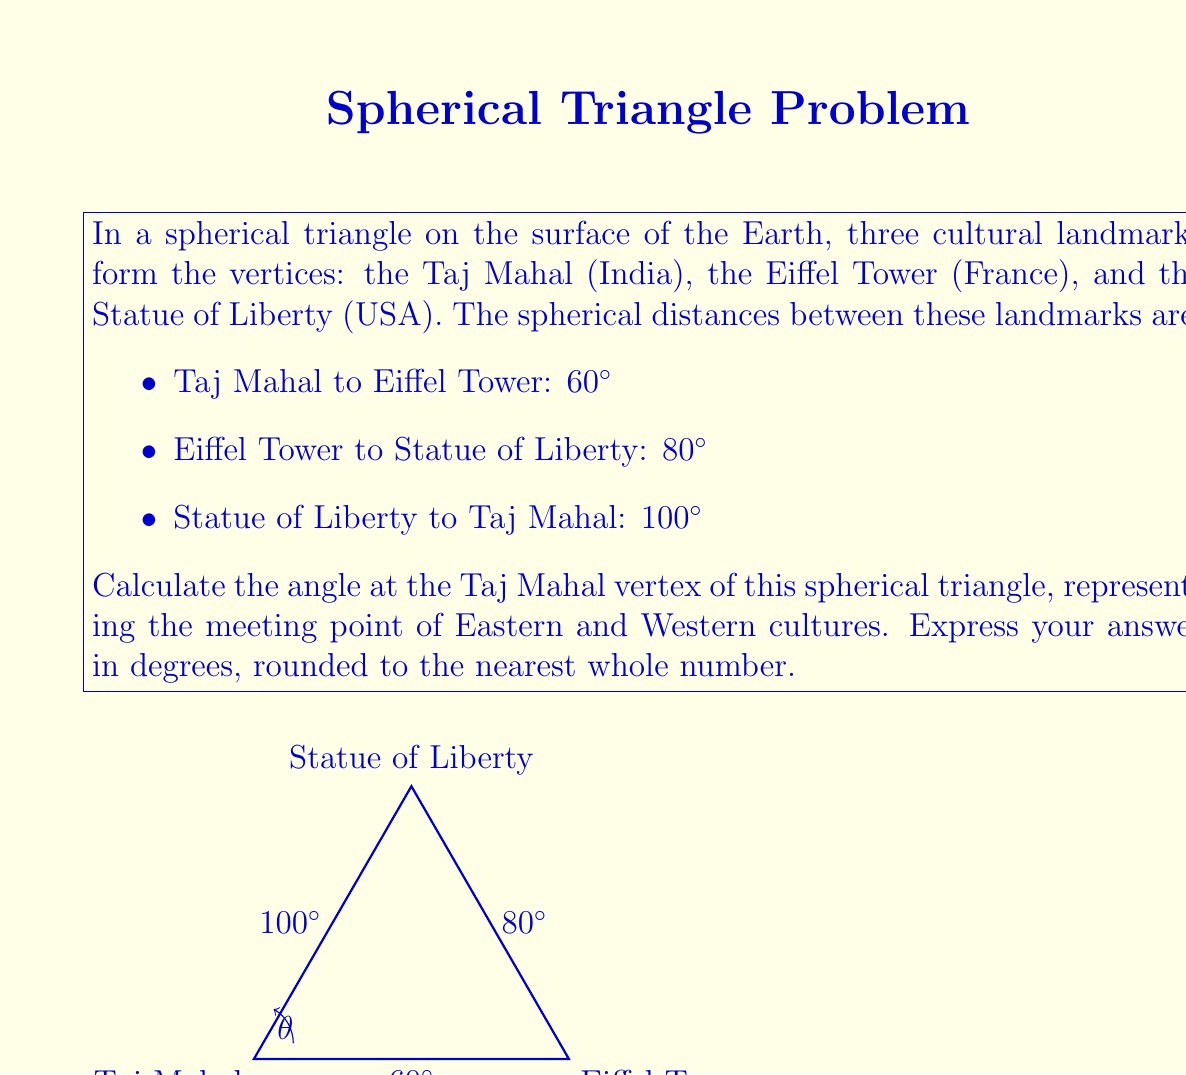Can you answer this question? To solve this problem, we'll use the spherical law of cosines. Let's denote the angle at the Taj Mahal as $\theta$, and the sides opposite to Taj Mahal, Eiffel Tower, and Statue of Liberty as $a$, $b$, and $c$ respectively.

Given:
$a = 80^\circ$, $b = 100^\circ$, $c = 60^\circ$

The spherical law of cosines states:

$$\cos(a) = \cos(b)\cos(c) + \sin(b)\sin(c)\cos(\theta)$$

Rearranging this equation to solve for $\cos(\theta)$:

$$\cos(\theta) = \frac{\cos(a) - \cos(b)\cos(c)}{\sin(b)\sin(c)}$$

Step 1: Calculate $\cos(a)$, $\cos(b)$, $\cos(c)$, $\sin(b)$, and $\sin(c)$
$\cos(80^\circ) \approx 0.1736$
$\cos(100^\circ) \approx -0.1736$
$\cos(60^\circ) = 0.5$
$\sin(100^\circ) \approx 0.9848$
$\sin(60^\circ) \approx 0.8660$

Step 2: Substitute these values into the equation
$$\cos(\theta) = \frac{0.1736 - (-0.1736 \times 0.5)}{0.9848 \times 0.8660}$$

Step 3: Simplify
$$\cos(\theta) = \frac{0.1736 + 0.0868}{0.8528} \approx 0.3055$$

Step 4: Take the inverse cosine (arccos) of both sides
$$\theta = \arccos(0.3055) \approx 72.2^\circ$$

Step 5: Round to the nearest whole number
$\theta \approx 72^\circ$

Therefore, the angle at the Taj Mahal vertex of the spherical triangle is approximately 72°.
Answer: $72^\circ$ 